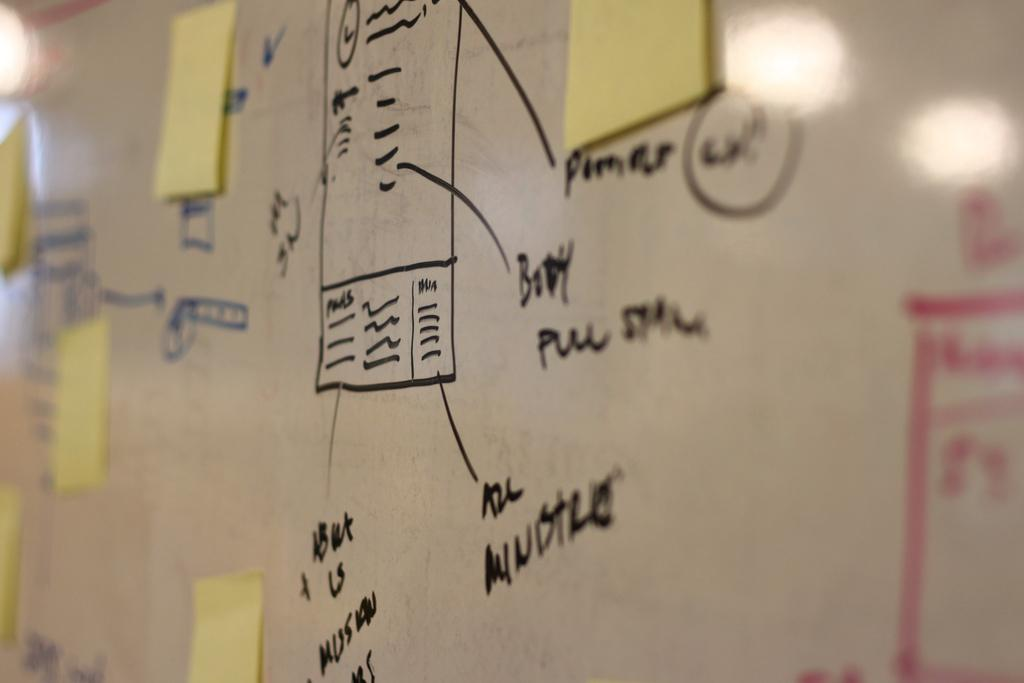What is attached to the board in the image? There are papers attached to the board in the image. What can be seen on the papers or board? There is text on the papers or board. What visual effect is present on the board? There are reflections of lights on the board. What type of underwear is visible on the board in the image? There is no underwear present on the board in the image. How many pancakes are stacked on the board in the image? There are no pancakes present on the board in the image. 